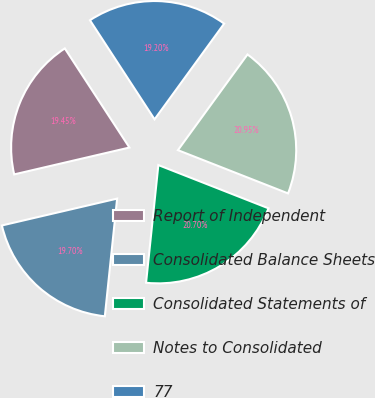Convert chart to OTSL. <chart><loc_0><loc_0><loc_500><loc_500><pie_chart><fcel>Report of Independent<fcel>Consolidated Balance Sheets<fcel>Consolidated Statements of<fcel>Notes to Consolidated<fcel>77<nl><fcel>19.45%<fcel>19.7%<fcel>20.7%<fcel>20.95%<fcel>19.2%<nl></chart> 